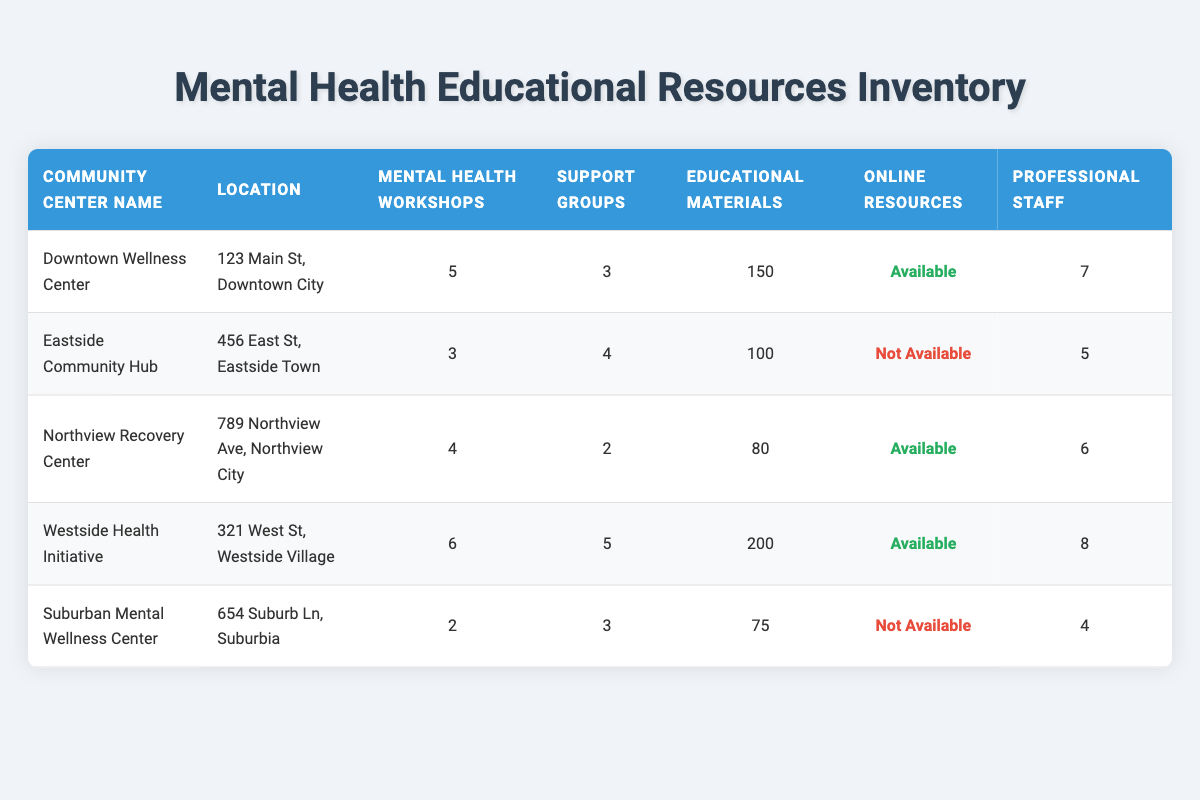What is the total number of mental health workshops available across all community centers? To find the total number of mental health workshops, add the workshops from each community center: 5 (Downtown) + 3 (Eastside) + 4 (Northview) + 6 (Westside) + 2 (Suburban) = 20.
Answer: 20 Which community center has the highest number of educational materials available? The educational materials values are: 150 (Downtown), 100 (Eastside), 80 (Northview), 200 (Westside), 75 (Suburban). The highest value is 200 at the Westside Health Initiative.
Answer: Westside Health Initiative Does the Northview Recovery Center have online resources available? The Northview Recovery Center has "Online Resources" marked as true.
Answer: Yes How many support groups are there at the Eastside Community Hub compared to the Suburban Mental Wellness Center? The Eastside Community Hub has 4 support groups, while the Suburban Mental Wellness Center has 3 support groups. The Eastside hub has 1 more support group than Suburban.
Answer: 1 more Which community center offers the least amount of mental health workshops, and how many are there? The Suburban Mental Wellness Center offers only 2 mental health workshops, which is the lowest count among all centers.
Answer: Suburban Mental Wellness Center, 2 How many professional staff members are present in total at the centers offering online resources? The centers with online resources are Downtown (7 staff), Northview (6 staff), and Westside (8 staff). Summing these gives: 7 + 6 + 8 = 21 professional staff members.
Answer: 21 Is there a community center with both online resources and the highest number of mental health workshops? Yes, the Westside Health Initiative has 6 mental health workshops and also offers online resources.
Answer: Yes What is the average number of educational materials available across all centers? The sum of educational materials is 150 (Downtown) + 100 (Eastside) + 80 (Northview) + 200 (Westside) + 75 (Suburban) = 605. There are 5 community centers, so the average is 605 / 5 = 121.
Answer: 121 